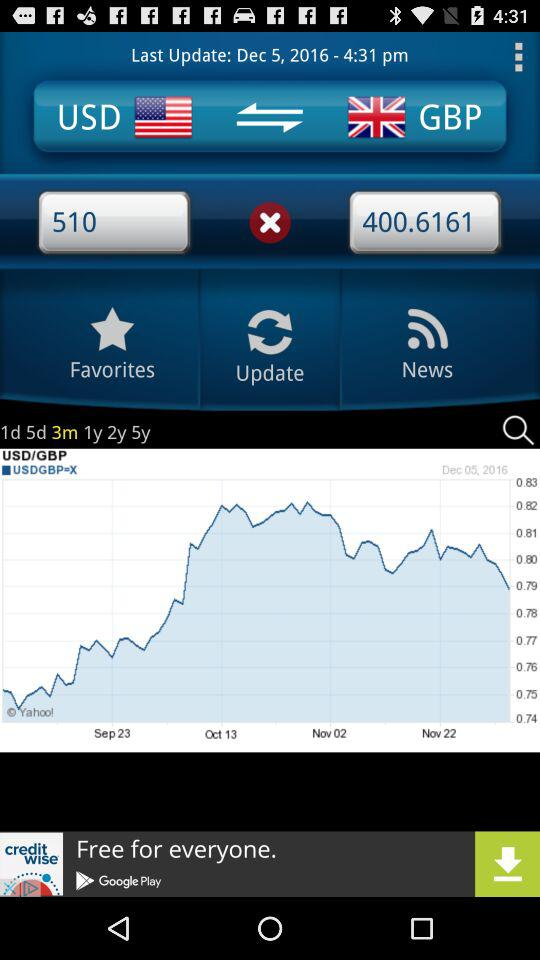What is the difference between the highest and lowest values in the graph?
Answer the question using a single word or phrase. 0.06 